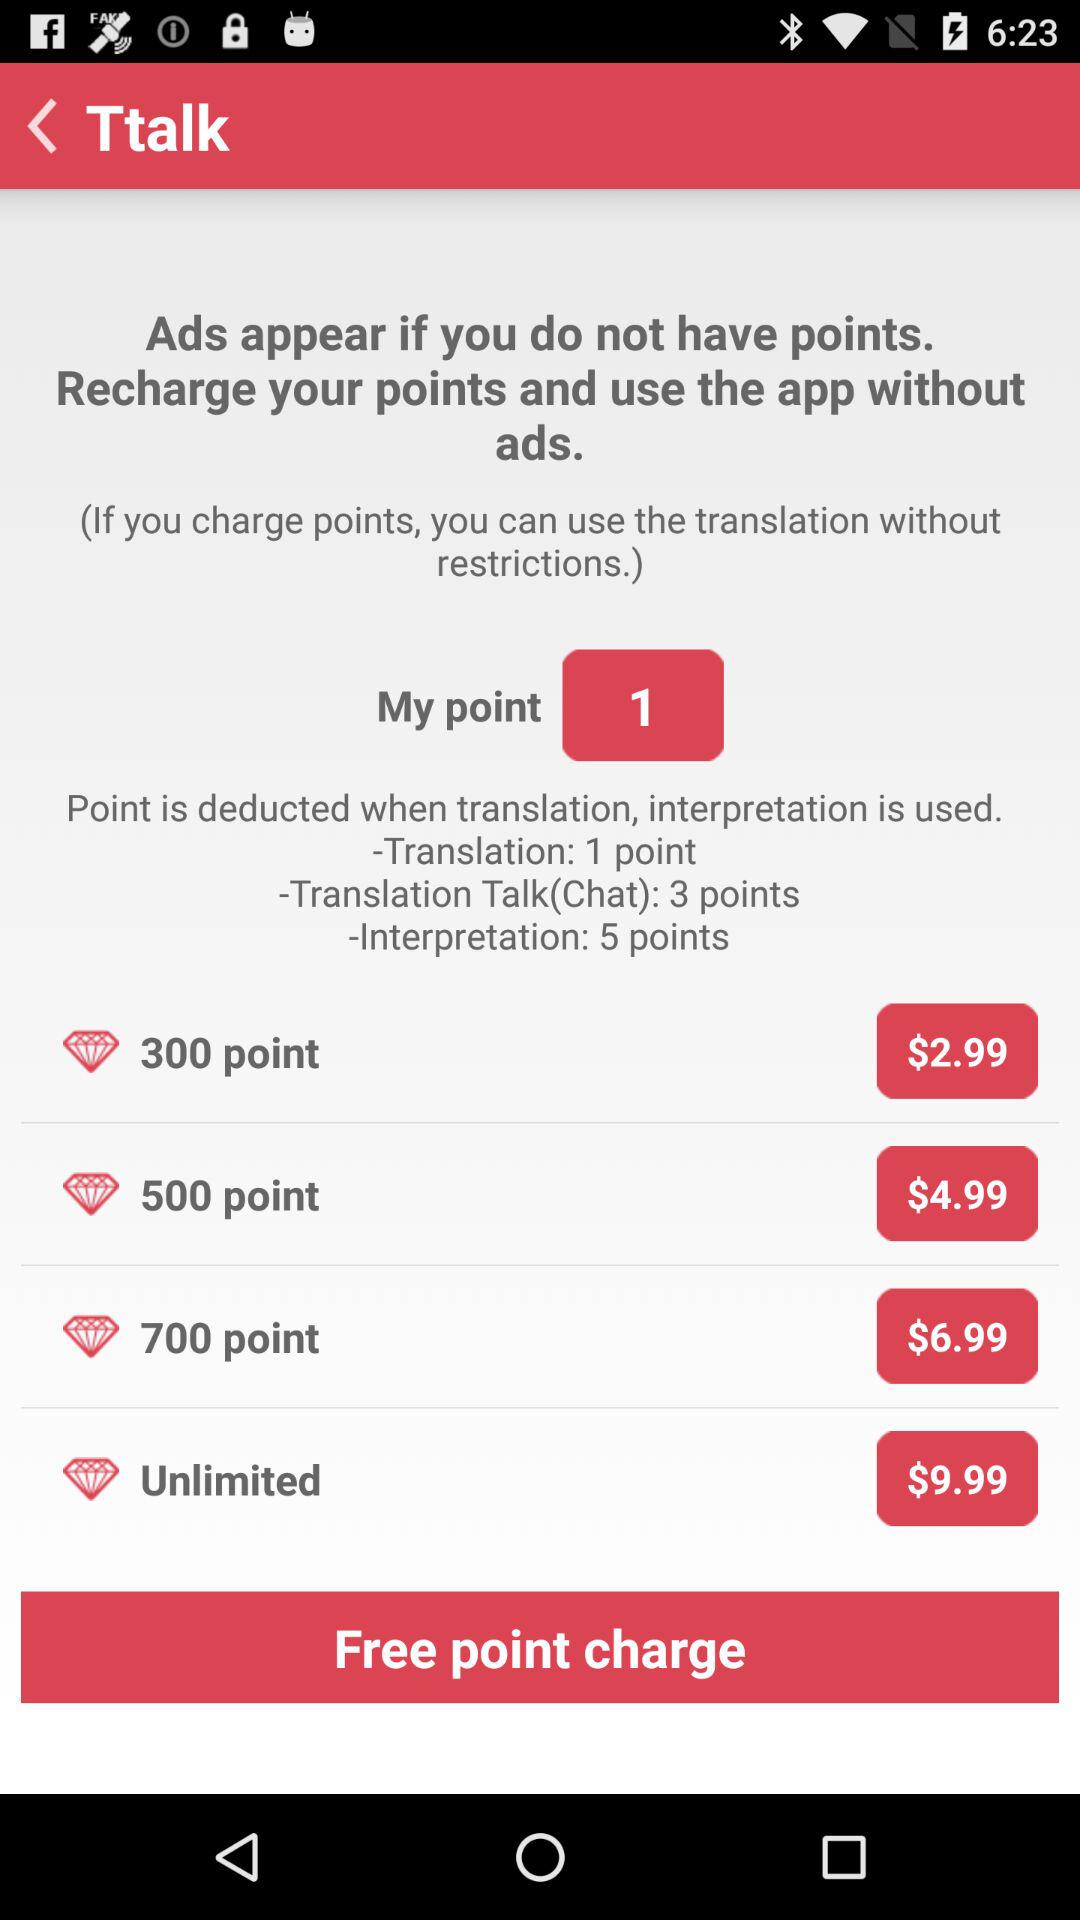How many points will be deducted if translation is used? The number of points that will be deducted if translation is used is 1. 